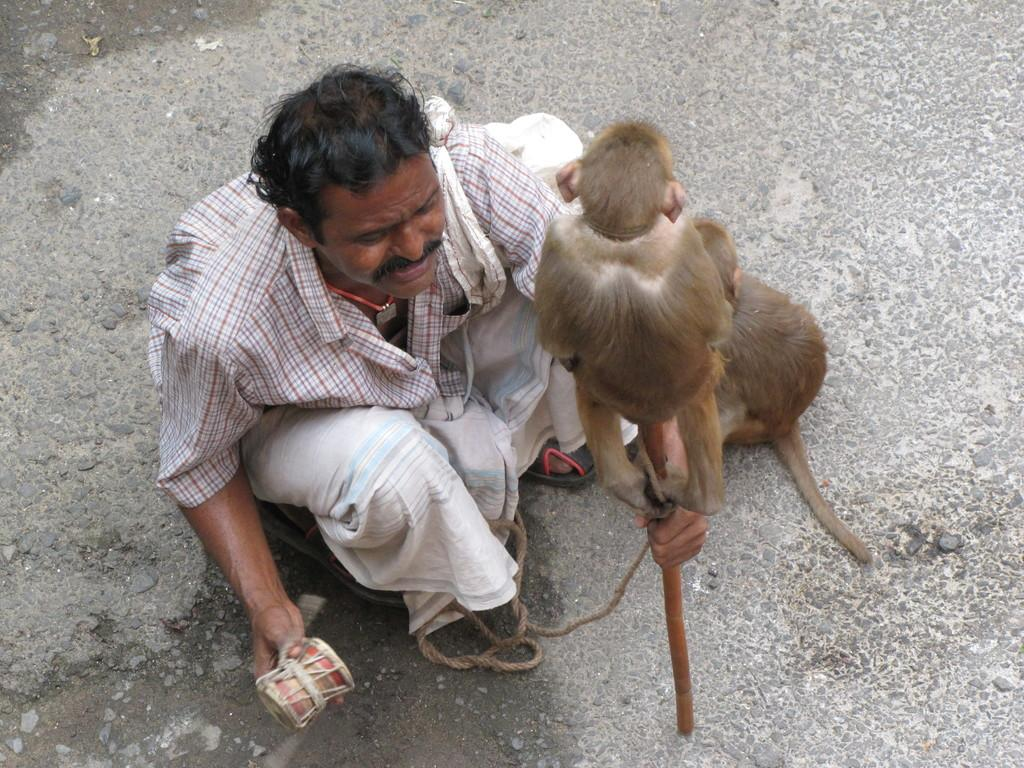What is the man in the image doing? The man is sitting on the ground in the image. What is the man holding in his hand? The man is holding a stick in his hand. Are there any animals present in the image? Yes, there are two monkeys in the image. What type of wrench is the man using to fix the nerve in the image? There is no wrench or nerve present in the image. The man is holding a stick, and there are two monkeys in the image. 